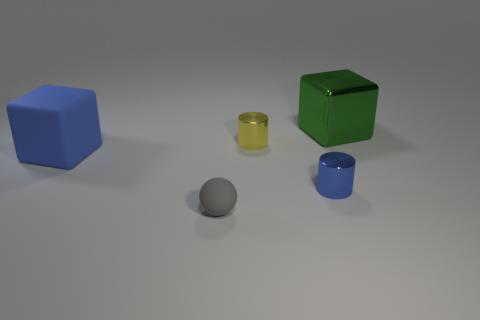The cube that is to the left of the large thing to the right of the tiny metal cylinder behind the tiny blue cylinder is what color?
Provide a succinct answer. Blue. There is a small metallic cylinder that is in front of the large matte object; does it have the same color as the large matte thing?
Your answer should be compact. Yes. What number of blue objects are both left of the tiny gray ball and in front of the blue cube?
Your answer should be compact. 0. What size is the other thing that is the same shape as the yellow object?
Provide a succinct answer. Small. What number of big cubes are to the left of the object that is in front of the small cylinder in front of the large blue cube?
Provide a succinct answer. 1. What is the color of the tiny metal cylinder in front of the small thing behind the big blue matte object?
Offer a terse response. Blue. What number of large metallic objects are on the left side of the cube that is in front of the small yellow cylinder?
Keep it short and to the point. 0. There is a metal object in front of the blue cube; is it the same color as the block on the left side of the gray rubber object?
Give a very brief answer. Yes. The small object behind the large cube left of the tiny blue thing is what shape?
Offer a terse response. Cylinder. There is a tiny metallic thing that is in front of the small thing behind the cube that is to the left of the tiny gray object; what is its shape?
Keep it short and to the point. Cylinder. 